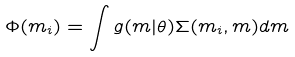Convert formula to latex. <formula><loc_0><loc_0><loc_500><loc_500>\Phi ( m _ { i } ) = \int g ( m | \theta ) \Sigma ( m _ { i } , m ) d m</formula> 